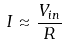<formula> <loc_0><loc_0><loc_500><loc_500>I \approx { \frac { V _ { i n } } { R } }</formula> 